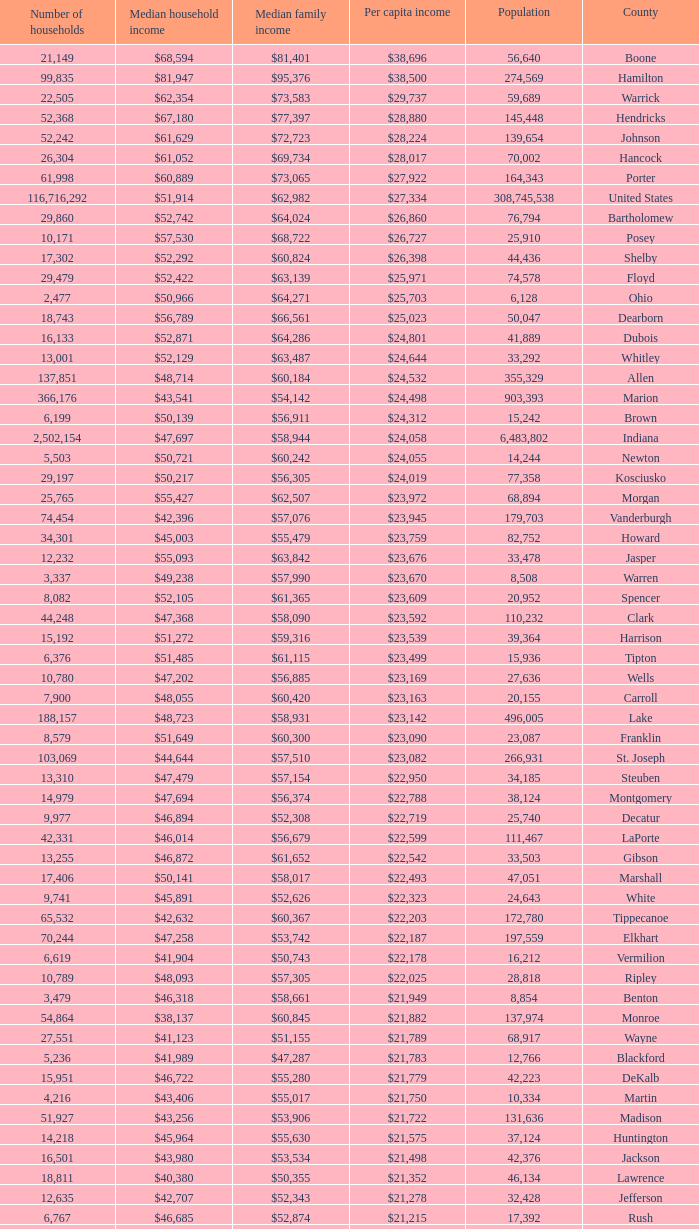What County has a Median household income of $46,872? Gibson. 